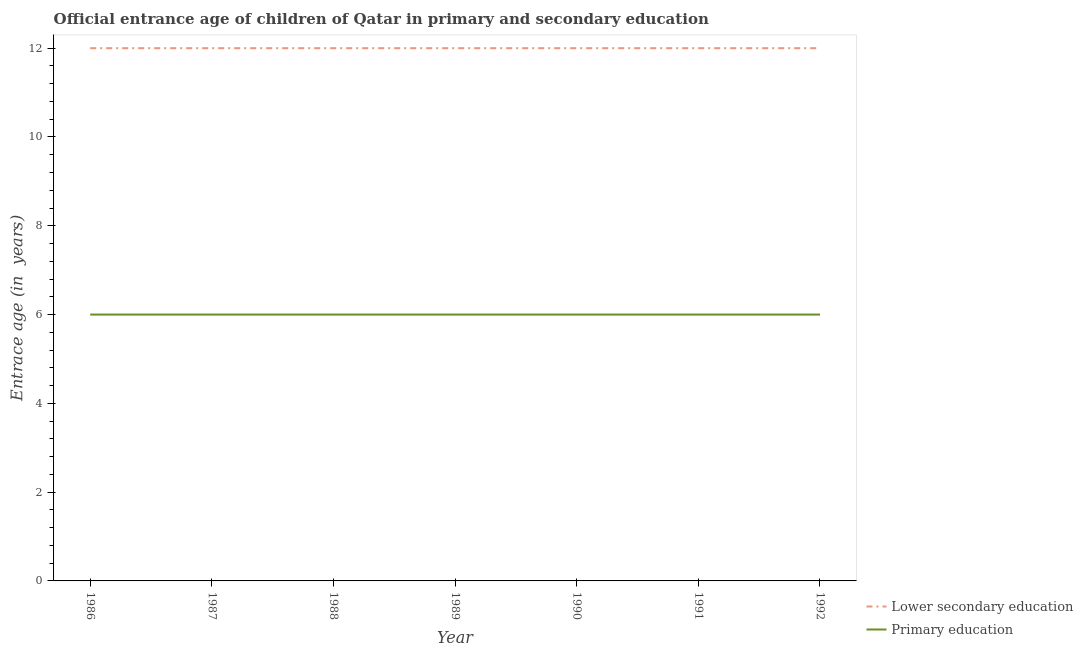How many different coloured lines are there?
Your answer should be compact. 2. Does the line corresponding to entrance age of chiildren in primary education intersect with the line corresponding to entrance age of children in lower secondary education?
Offer a very short reply. No. Across all years, what is the maximum entrance age of children in lower secondary education?
Ensure brevity in your answer.  12. Across all years, what is the minimum entrance age of chiildren in primary education?
Make the answer very short. 6. In which year was the entrance age of children in lower secondary education maximum?
Make the answer very short. 1986. In which year was the entrance age of children in lower secondary education minimum?
Offer a very short reply. 1986. What is the total entrance age of children in lower secondary education in the graph?
Provide a short and direct response. 84. What is the difference between the entrance age of chiildren in primary education in 1991 and the entrance age of children in lower secondary education in 1992?
Your answer should be compact. -6. In how many years, is the entrance age of children in lower secondary education greater than 7.2 years?
Ensure brevity in your answer.  7. What is the ratio of the entrance age of children in lower secondary education in 1986 to that in 1988?
Your answer should be very brief. 1. Is the entrance age of children in lower secondary education in 1990 less than that in 1991?
Offer a very short reply. No. Is the difference between the entrance age of chiildren in primary education in 1988 and 1992 greater than the difference between the entrance age of children in lower secondary education in 1988 and 1992?
Make the answer very short. No. What is the difference between the highest and the lowest entrance age of children in lower secondary education?
Keep it short and to the point. 0. Is the sum of the entrance age of children in lower secondary education in 1986 and 1989 greater than the maximum entrance age of chiildren in primary education across all years?
Offer a very short reply. Yes. Is the entrance age of chiildren in primary education strictly less than the entrance age of children in lower secondary education over the years?
Make the answer very short. Yes. How many years are there in the graph?
Your response must be concise. 7. Are the values on the major ticks of Y-axis written in scientific E-notation?
Provide a short and direct response. No. Does the graph contain grids?
Offer a very short reply. No. How are the legend labels stacked?
Keep it short and to the point. Vertical. What is the title of the graph?
Your answer should be compact. Official entrance age of children of Qatar in primary and secondary education. What is the label or title of the Y-axis?
Offer a terse response. Entrace age (in  years). What is the Entrace age (in  years) of Lower secondary education in 1986?
Your response must be concise. 12. What is the Entrace age (in  years) of Lower secondary education in 1987?
Provide a short and direct response. 12. What is the Entrace age (in  years) in Primary education in 1987?
Keep it short and to the point. 6. What is the Entrace age (in  years) of Primary education in 1988?
Give a very brief answer. 6. What is the Entrace age (in  years) in Primary education in 1989?
Offer a very short reply. 6. What is the Entrace age (in  years) in Lower secondary education in 1990?
Your response must be concise. 12. What is the Entrace age (in  years) of Primary education in 1990?
Offer a very short reply. 6. What is the Entrace age (in  years) of Lower secondary education in 1991?
Offer a very short reply. 12. What is the Entrace age (in  years) in Lower secondary education in 1992?
Ensure brevity in your answer.  12. Across all years, what is the minimum Entrace age (in  years) of Primary education?
Provide a short and direct response. 6. What is the difference between the Entrace age (in  years) of Lower secondary education in 1986 and that in 1987?
Make the answer very short. 0. What is the difference between the Entrace age (in  years) of Lower secondary education in 1986 and that in 1988?
Give a very brief answer. 0. What is the difference between the Entrace age (in  years) of Primary education in 1986 and that in 1988?
Your answer should be compact. 0. What is the difference between the Entrace age (in  years) of Lower secondary education in 1986 and that in 1991?
Make the answer very short. 0. What is the difference between the Entrace age (in  years) of Primary education in 1986 and that in 1991?
Your answer should be compact. 0. What is the difference between the Entrace age (in  years) of Lower secondary education in 1986 and that in 1992?
Keep it short and to the point. 0. What is the difference between the Entrace age (in  years) of Lower secondary education in 1987 and that in 1988?
Offer a terse response. 0. What is the difference between the Entrace age (in  years) in Primary education in 1987 and that in 1988?
Make the answer very short. 0. What is the difference between the Entrace age (in  years) in Lower secondary education in 1987 and that in 1989?
Keep it short and to the point. 0. What is the difference between the Entrace age (in  years) of Lower secondary education in 1987 and that in 1990?
Ensure brevity in your answer.  0. What is the difference between the Entrace age (in  years) in Lower secondary education in 1987 and that in 1991?
Make the answer very short. 0. What is the difference between the Entrace age (in  years) of Lower secondary education in 1987 and that in 1992?
Offer a very short reply. 0. What is the difference between the Entrace age (in  years) of Primary education in 1988 and that in 1990?
Offer a very short reply. 0. What is the difference between the Entrace age (in  years) of Lower secondary education in 1988 and that in 1991?
Offer a terse response. 0. What is the difference between the Entrace age (in  years) in Lower secondary education in 1988 and that in 1992?
Make the answer very short. 0. What is the difference between the Entrace age (in  years) of Primary education in 1988 and that in 1992?
Your answer should be very brief. 0. What is the difference between the Entrace age (in  years) in Primary education in 1989 and that in 1990?
Offer a very short reply. 0. What is the difference between the Entrace age (in  years) of Primary education in 1989 and that in 1991?
Provide a short and direct response. 0. What is the difference between the Entrace age (in  years) in Primary education in 1990 and that in 1991?
Ensure brevity in your answer.  0. What is the difference between the Entrace age (in  years) of Lower secondary education in 1990 and that in 1992?
Offer a very short reply. 0. What is the difference between the Entrace age (in  years) in Primary education in 1991 and that in 1992?
Make the answer very short. 0. What is the difference between the Entrace age (in  years) of Lower secondary education in 1986 and the Entrace age (in  years) of Primary education in 1989?
Provide a succinct answer. 6. What is the difference between the Entrace age (in  years) in Lower secondary education in 1986 and the Entrace age (in  years) in Primary education in 1990?
Your answer should be compact. 6. What is the difference between the Entrace age (in  years) of Lower secondary education in 1986 and the Entrace age (in  years) of Primary education in 1991?
Your answer should be very brief. 6. What is the difference between the Entrace age (in  years) of Lower secondary education in 1986 and the Entrace age (in  years) of Primary education in 1992?
Keep it short and to the point. 6. What is the difference between the Entrace age (in  years) of Lower secondary education in 1987 and the Entrace age (in  years) of Primary education in 1992?
Give a very brief answer. 6. What is the difference between the Entrace age (in  years) of Lower secondary education in 1988 and the Entrace age (in  years) of Primary education in 1989?
Your answer should be very brief. 6. What is the difference between the Entrace age (in  years) in Lower secondary education in 1988 and the Entrace age (in  years) in Primary education in 1990?
Offer a very short reply. 6. What is the difference between the Entrace age (in  years) in Lower secondary education in 1989 and the Entrace age (in  years) in Primary education in 1991?
Make the answer very short. 6. What is the difference between the Entrace age (in  years) in Lower secondary education in 1990 and the Entrace age (in  years) in Primary education in 1991?
Make the answer very short. 6. What is the average Entrace age (in  years) of Primary education per year?
Your answer should be very brief. 6. In the year 1987, what is the difference between the Entrace age (in  years) in Lower secondary education and Entrace age (in  years) in Primary education?
Provide a succinct answer. 6. In the year 1988, what is the difference between the Entrace age (in  years) in Lower secondary education and Entrace age (in  years) in Primary education?
Offer a terse response. 6. In the year 1990, what is the difference between the Entrace age (in  years) of Lower secondary education and Entrace age (in  years) of Primary education?
Make the answer very short. 6. In the year 1992, what is the difference between the Entrace age (in  years) of Lower secondary education and Entrace age (in  years) of Primary education?
Ensure brevity in your answer.  6. What is the ratio of the Entrace age (in  years) in Lower secondary education in 1986 to that in 1989?
Offer a terse response. 1. What is the ratio of the Entrace age (in  years) of Primary education in 1986 to that in 1989?
Provide a short and direct response. 1. What is the ratio of the Entrace age (in  years) of Lower secondary education in 1986 to that in 1990?
Offer a very short reply. 1. What is the ratio of the Entrace age (in  years) of Primary education in 1986 to that in 1991?
Your answer should be very brief. 1. What is the ratio of the Entrace age (in  years) of Lower secondary education in 1986 to that in 1992?
Your answer should be compact. 1. What is the ratio of the Entrace age (in  years) of Primary education in 1986 to that in 1992?
Give a very brief answer. 1. What is the ratio of the Entrace age (in  years) in Lower secondary education in 1987 to that in 1988?
Your response must be concise. 1. What is the ratio of the Entrace age (in  years) in Primary education in 1987 to that in 1988?
Offer a terse response. 1. What is the ratio of the Entrace age (in  years) of Primary education in 1987 to that in 1989?
Give a very brief answer. 1. What is the ratio of the Entrace age (in  years) in Lower secondary education in 1987 to that in 1991?
Provide a short and direct response. 1. What is the ratio of the Entrace age (in  years) of Primary education in 1987 to that in 1992?
Your answer should be very brief. 1. What is the ratio of the Entrace age (in  years) of Lower secondary education in 1988 to that in 1989?
Keep it short and to the point. 1. What is the ratio of the Entrace age (in  years) of Lower secondary education in 1988 to that in 1990?
Offer a very short reply. 1. What is the ratio of the Entrace age (in  years) of Primary education in 1988 to that in 1992?
Your answer should be compact. 1. What is the ratio of the Entrace age (in  years) in Lower secondary education in 1989 to that in 1990?
Provide a succinct answer. 1. What is the ratio of the Entrace age (in  years) in Lower secondary education in 1989 to that in 1991?
Make the answer very short. 1. What is the ratio of the Entrace age (in  years) of Primary education in 1989 to that in 1991?
Provide a short and direct response. 1. What is the ratio of the Entrace age (in  years) in Lower secondary education in 1989 to that in 1992?
Keep it short and to the point. 1. What is the ratio of the Entrace age (in  years) in Lower secondary education in 1990 to that in 1991?
Ensure brevity in your answer.  1. What is the ratio of the Entrace age (in  years) of Lower secondary education in 1990 to that in 1992?
Your response must be concise. 1. What is the ratio of the Entrace age (in  years) of Lower secondary education in 1991 to that in 1992?
Provide a succinct answer. 1. What is the difference between the highest and the second highest Entrace age (in  years) in Primary education?
Make the answer very short. 0. 